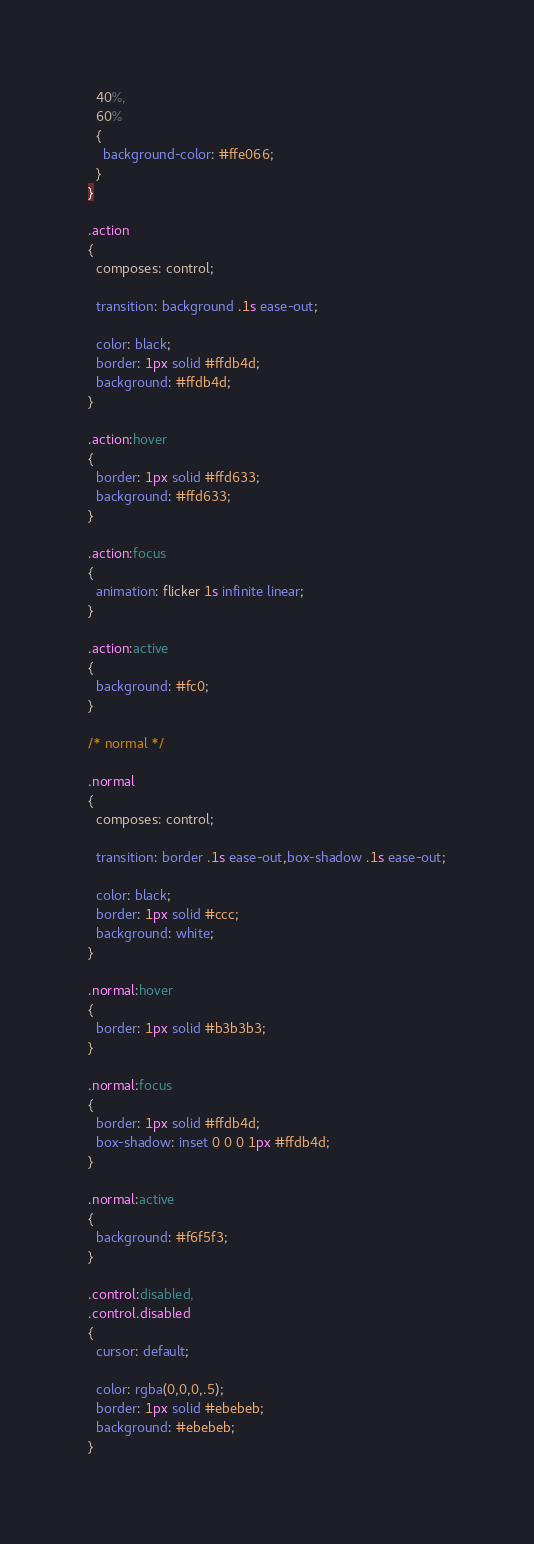Convert code to text. <code><loc_0><loc_0><loc_500><loc_500><_CSS_>  40%,
  60%
  {
    background-color: #ffe066;
  }
}

.action
{
  composes: control;

  transition: background .1s ease-out;

  color: black;
  border: 1px solid #ffdb4d;
  background: #ffdb4d;
}

.action:hover
{
  border: 1px solid #ffd633;
  background: #ffd633;
}

.action:focus
{
  animation: flicker 1s infinite linear;
}

.action:active
{
  background: #fc0;
}

/* normal */

.normal
{
  composes: control;

  transition: border .1s ease-out,box-shadow .1s ease-out;

  color: black;
  border: 1px solid #ccc;
  background: white;
}

.normal:hover
{
  border: 1px solid #b3b3b3;
}

.normal:focus
{
  border: 1px solid #ffdb4d;
  box-shadow: inset 0 0 0 1px #ffdb4d;
}

.normal:active
{
  background: #f6f5f3;
}

.control:disabled,
.control.disabled
{
  cursor: default;

  color: rgba(0,0,0,.5);
  border: 1px solid #ebebeb;
  background: #ebebeb;
}
</code> 